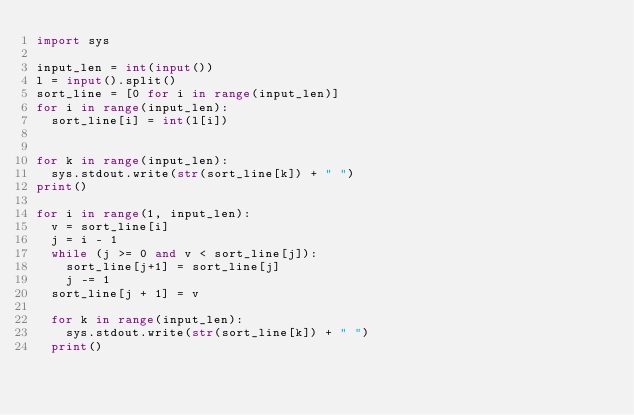Convert code to text. <code><loc_0><loc_0><loc_500><loc_500><_Python_>import sys

input_len = int(input())
l = input().split()
sort_line = [0 for i in range(input_len)]
for i in range(input_len):
	sort_line[i] = int(l[i])
	

for k in range(input_len):
	sys.stdout.write(str(sort_line[k]) + " ")
print()

for i in range(1, input_len):
	v = sort_line[i]
	j = i - 1
	while (j >= 0 and v < sort_line[j]):
		sort_line[j+1] = sort_line[j]
		j -= 1
	sort_line[j + 1] = v

	for k in range(input_len):
		sys.stdout.write(str(sort_line[k]) + " ")
	print()
</code> 